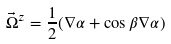Convert formula to latex. <formula><loc_0><loc_0><loc_500><loc_500>\vec { \Omega } ^ { z } = \frac { 1 } { 2 } ( \nabla \alpha + \cos \beta \nabla \alpha )</formula> 